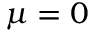<formula> <loc_0><loc_0><loc_500><loc_500>\mu = 0</formula> 